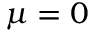<formula> <loc_0><loc_0><loc_500><loc_500>\mu = 0</formula> 